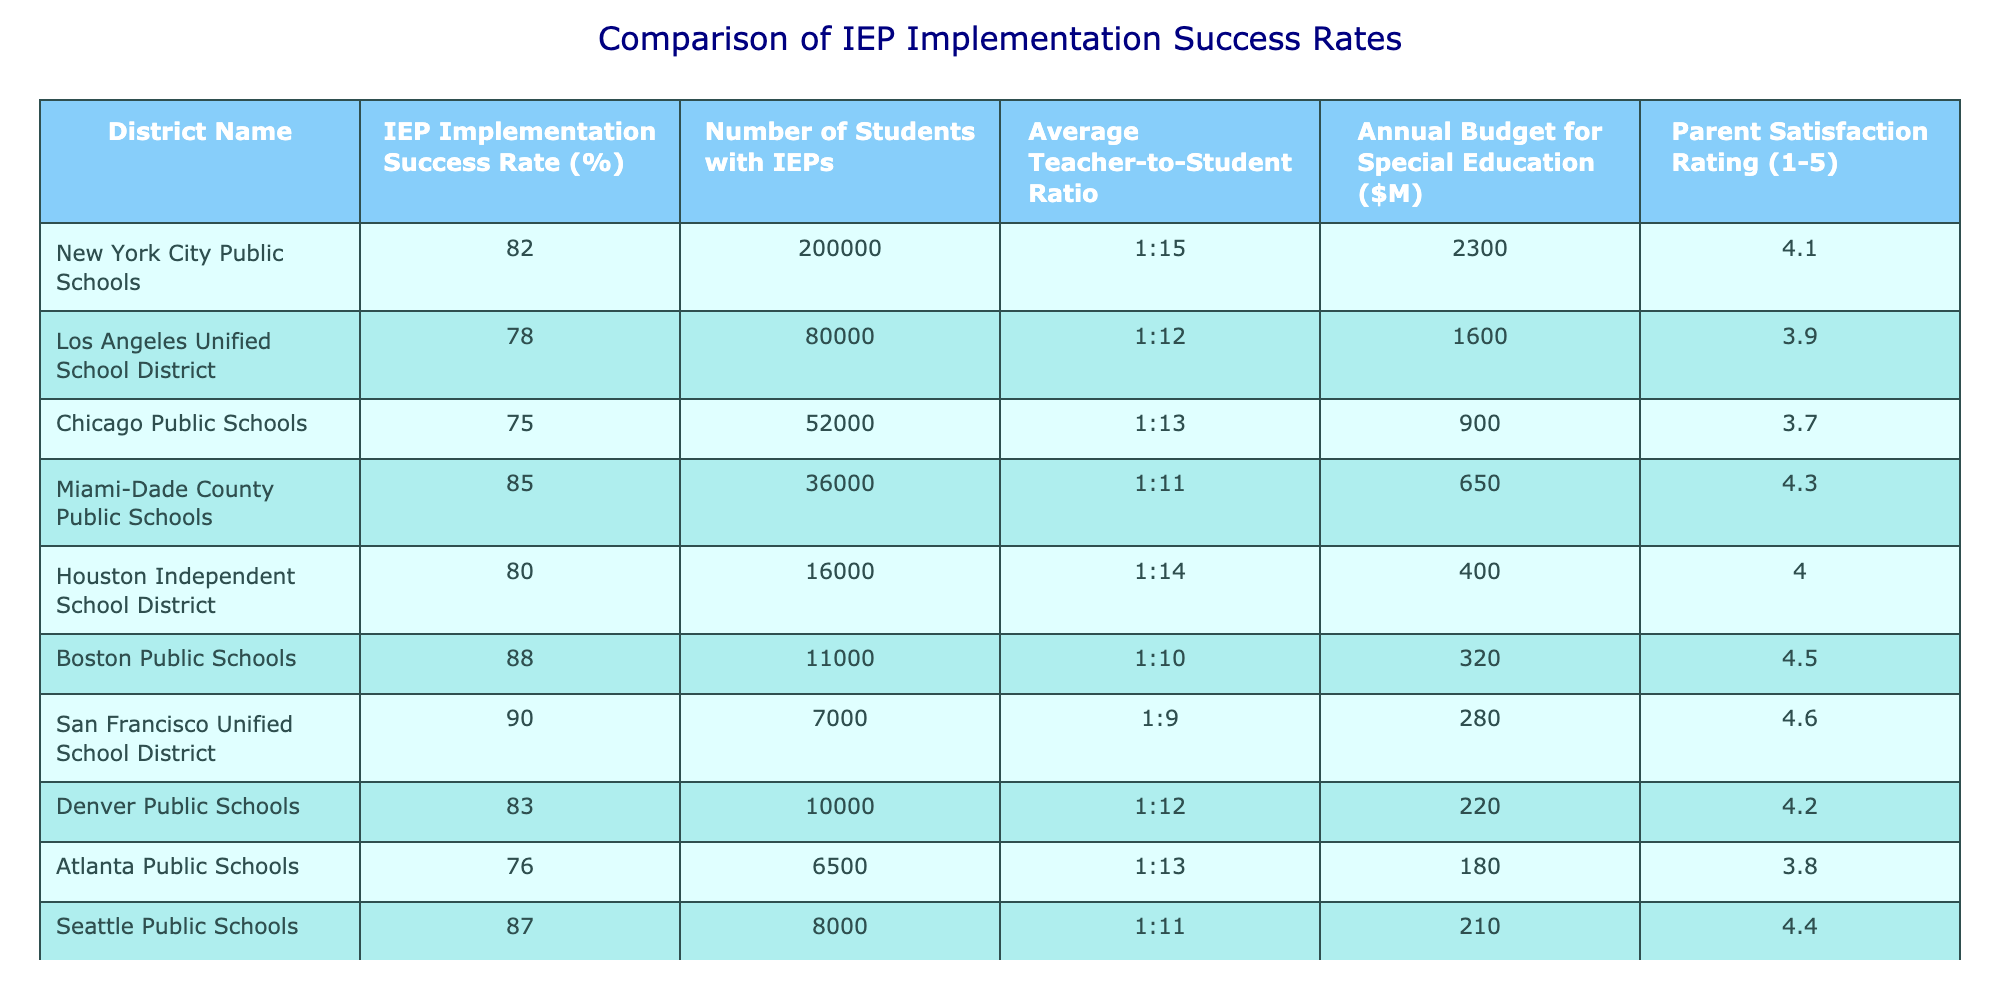What is the IEP implementation success rate for Miami-Dade County Public Schools? The IEP implementation success rate for Miami-Dade County Public Schools is listed in the table. It is explicitly provided as 85%.
Answer: 85% Which school district has the highest parent satisfaction rating? By examining the Parent Satisfaction Rating column, we see that San Francisco Unified School District has the highest rating at 4.6.
Answer: 4.6 How many students with IEPs are in Los Angeles Unified School District? The table shows that the number of students with IEPs in Los Angeles Unified School District is 80,000.
Answer: 80,000 What is the average IEP implementation success rate for the districts listed? To find the average IEP implementation success rate, we sum all the rates (82 + 78 + 75 + 85 + 80 + 88 + 90 + 83 + 76 + 87) which equals  84.4, and since there are 10 districts, we divide by 10: 844 / 10 = 84.4.
Answer: 84.4 Is the average teacher-to-student ratio lower than 1:12 across all districts? First, we note the different ratios and convert them to numbers for comparison. The average ratio calculated is approximately 1:12.5, which is higher than 1:12.
Answer: No What is the difference in the IEP implementation success rates between Boston Public Schools and Atlanta Public Schools? Boston Public Schools has a success rate of 88% and Atlanta Public Schools has 76%. To find the difference, we subtract 76 from 88, giving us 12%.
Answer: 12% Do districts with higher annual budgets for special education tend to have higher IEP implementation success rates? Looking at the data, we check for a correlation between budget and success rates. For example, San Francisco, which has the highest success rate (90%), also has a lower budget compared to others like New York City. Thus, the relationship is not clear-cut.
Answer: No Which district has the lowest average teacher-to-student ratio? By examining the ratios provided, San Francisco Unified School District has the lowest ratio at 1:9.
Answer: 1:9 How many districts have an IEP implementation success rate of over 80%? From the table, the districts with rates above 80% are New York City (82%), Miami-Dade (85%), Boston (88%), San Francisco (90%), Denver (83%), and Seattle (87%). This totals to 6 districts.
Answer: 6 What is the total number of students with IEPs across all districts? We sum the number of students with IEPs in each district (200,000 + 80,000 + 52,000 + 36,000 + 16,000 + 11,000 + 7,000 + 10,000 + 6,500 + 8,000) which equals 400,500.
Answer: 400,500 